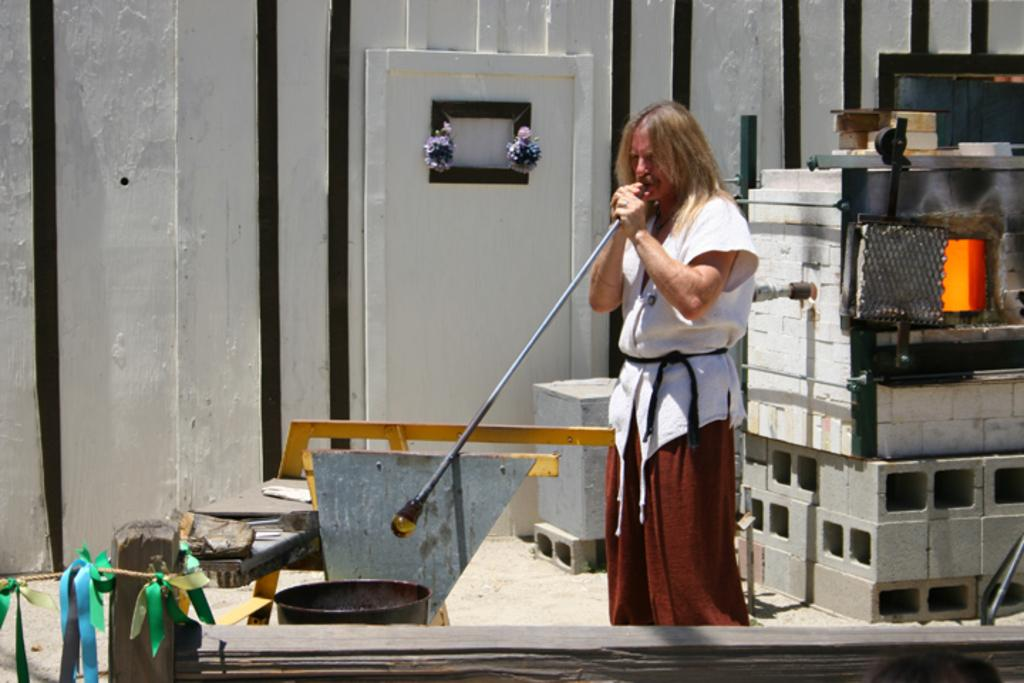Who or what is present in the image? There is a person in the image. What is the person holding in the image? The person is holding a metal rod. What can be seen behind the person in the image? There are bricks visible behind the person. What type of test is the person conducting with the metal rod in the image? There is no indication in the image that the person is conducting a test or using the metal rod for any specific purpose. 